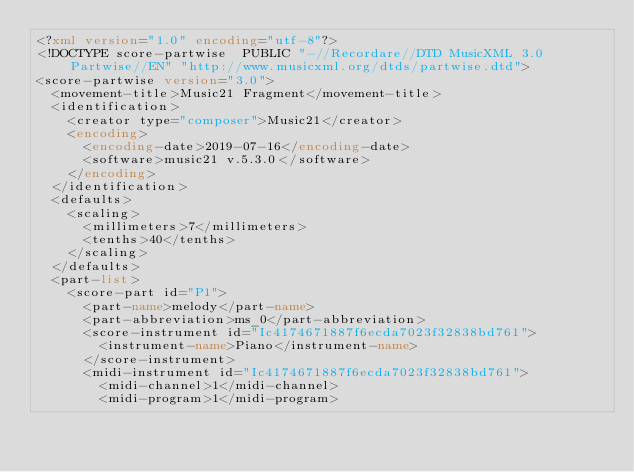Convert code to text. <code><loc_0><loc_0><loc_500><loc_500><_XML_><?xml version="1.0" encoding="utf-8"?>
<!DOCTYPE score-partwise  PUBLIC "-//Recordare//DTD MusicXML 3.0 Partwise//EN" "http://www.musicxml.org/dtds/partwise.dtd">
<score-partwise version="3.0">
  <movement-title>Music21 Fragment</movement-title>
  <identification>
    <creator type="composer">Music21</creator>
    <encoding>
      <encoding-date>2019-07-16</encoding-date>
      <software>music21 v.5.3.0</software>
    </encoding>
  </identification>
  <defaults>
    <scaling>
      <millimeters>7</millimeters>
      <tenths>40</tenths>
    </scaling>
  </defaults>
  <part-list>
    <score-part id="P1">
      <part-name>melody</part-name>
      <part-abbreviation>ms_0</part-abbreviation>
      <score-instrument id="Ic4174671887f6ecda7023f32838bd761">
        <instrument-name>Piano</instrument-name>
      </score-instrument>
      <midi-instrument id="Ic4174671887f6ecda7023f32838bd761">
        <midi-channel>1</midi-channel>
        <midi-program>1</midi-program></code> 